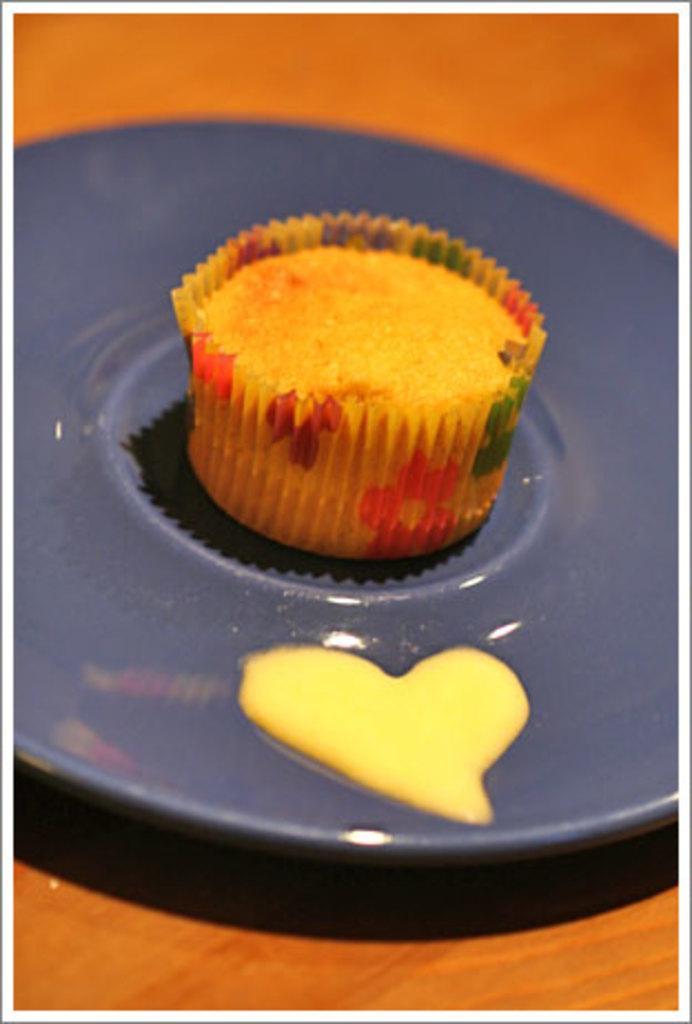In one or two sentences, can you explain what this image depicts? In this picture we can see a table. On the table we can see a plate which contains a cupcake. 